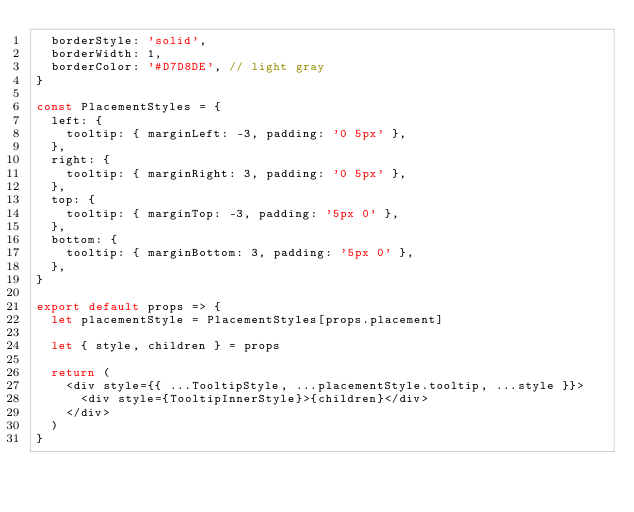<code> <loc_0><loc_0><loc_500><loc_500><_JavaScript_>  borderStyle: 'solid',
  borderWidth: 1,
  borderColor: '#D7D8DE', // light gray
}

const PlacementStyles = {
  left: {
    tooltip: { marginLeft: -3, padding: '0 5px' },
  },
  right: {
    tooltip: { marginRight: 3, padding: '0 5px' },
  },
  top: {
    tooltip: { marginTop: -3, padding: '5px 0' },
  },
  bottom: {
    tooltip: { marginBottom: 3, padding: '5px 0' },
  },
}

export default props => {
  let placementStyle = PlacementStyles[props.placement]

  let { style, children } = props

  return (
    <div style={{ ...TooltipStyle, ...placementStyle.tooltip, ...style }}>
      <div style={TooltipInnerStyle}>{children}</div>
    </div>
  )
}
</code> 